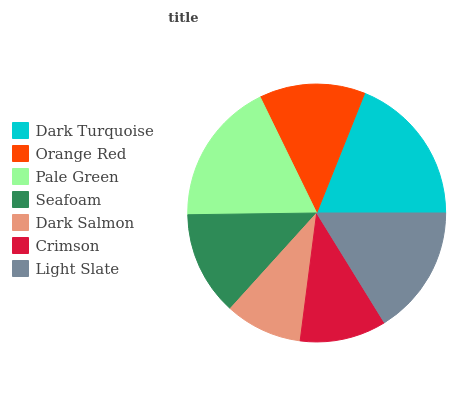Is Dark Salmon the minimum?
Answer yes or no. Yes. Is Dark Turquoise the maximum?
Answer yes or no. Yes. Is Orange Red the minimum?
Answer yes or no. No. Is Orange Red the maximum?
Answer yes or no. No. Is Dark Turquoise greater than Orange Red?
Answer yes or no. Yes. Is Orange Red less than Dark Turquoise?
Answer yes or no. Yes. Is Orange Red greater than Dark Turquoise?
Answer yes or no. No. Is Dark Turquoise less than Orange Red?
Answer yes or no. No. Is Orange Red the high median?
Answer yes or no. Yes. Is Orange Red the low median?
Answer yes or no. Yes. Is Dark Turquoise the high median?
Answer yes or no. No. Is Crimson the low median?
Answer yes or no. No. 